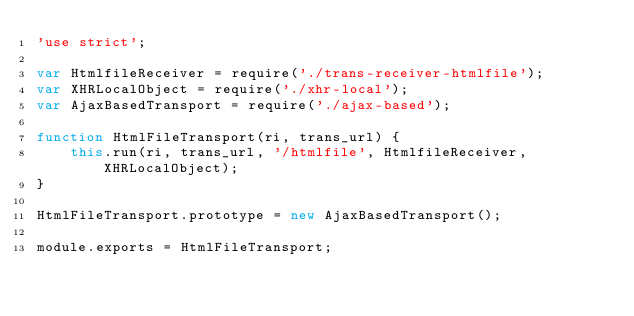<code> <loc_0><loc_0><loc_500><loc_500><_JavaScript_>'use strict';

var HtmlfileReceiver = require('./trans-receiver-htmlfile');
var XHRLocalObject = require('./xhr-local');
var AjaxBasedTransport = require('./ajax-based');

function HtmlFileTransport(ri, trans_url) {
    this.run(ri, trans_url, '/htmlfile', HtmlfileReceiver, XHRLocalObject);
}

HtmlFileTransport.prototype = new AjaxBasedTransport();

module.exports = HtmlFileTransport;</code> 